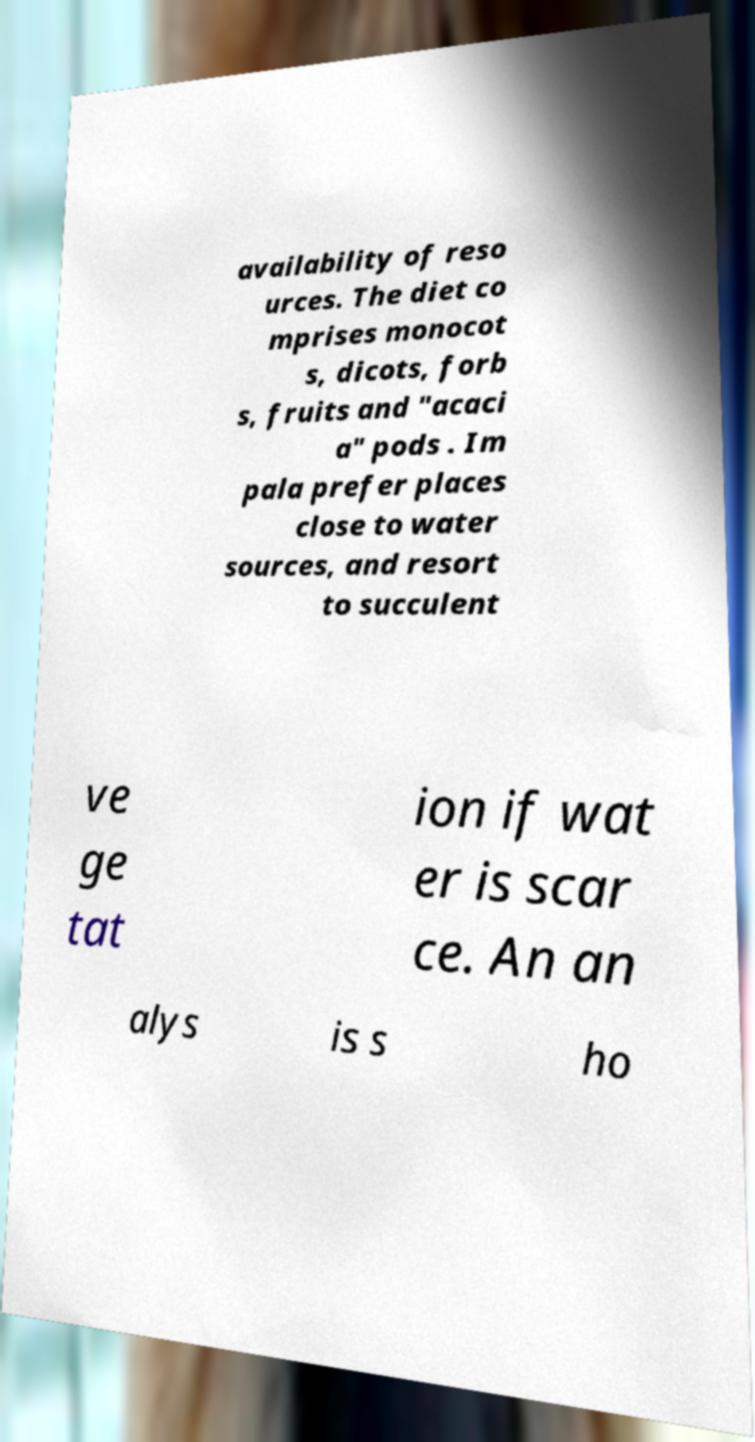Could you assist in decoding the text presented in this image and type it out clearly? availability of reso urces. The diet co mprises monocot s, dicots, forb s, fruits and "acaci a" pods . Im pala prefer places close to water sources, and resort to succulent ve ge tat ion if wat er is scar ce. An an alys is s ho 